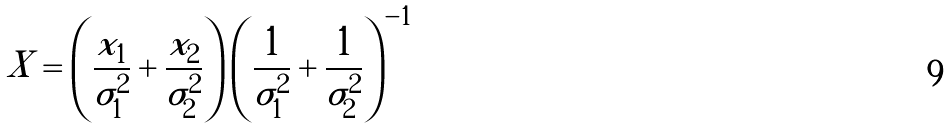<formula> <loc_0><loc_0><loc_500><loc_500>X = \left ( \frac { x _ { 1 } } { \sigma _ { 1 } ^ { 2 } } + \frac { x _ { 2 } } { \sigma _ { 2 } ^ { 2 } } \right ) \left ( \frac { 1 } { \sigma _ { 1 } ^ { 2 } } + \frac { 1 } { \sigma _ { 2 } ^ { 2 } } \right ) ^ { - 1 }</formula> 